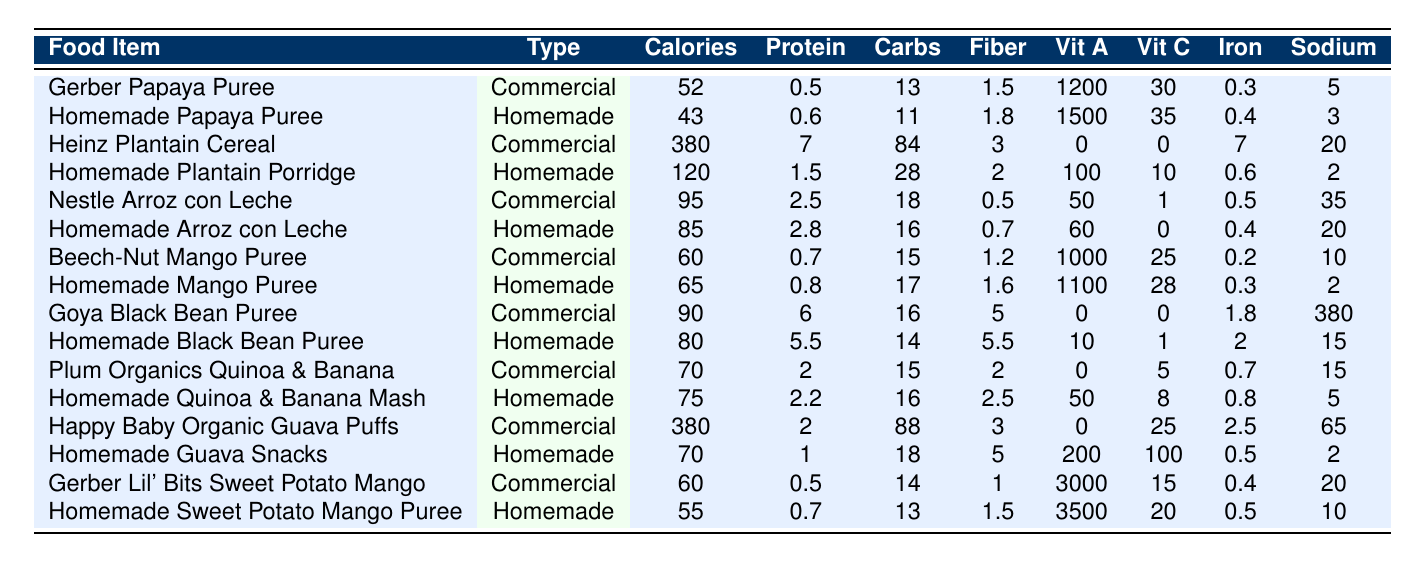What are the calories in Homemade Papaya Puree? The table shows that Homemade Papaya Puree contains 43 calories per 100 grams.
Answer: 43 calories Which food has the highest protein content: Commercial or Homemade? To determine this, we must compare the highest protein values from both categories. The highest protein in the Commercial category is Heinz Plantain Cereal with 7g, while in Homemade, it's Homemade Black Bean Puree with 5.5g. Therefore, Commercial has the highest protein.
Answer: Commercial What is the difference in fiber content between the Homemade and Commercial versions of Arroz con Leche? Homemade Arroz con Leche has 0.7g of fiber, while Commercial Arroz con Leche has 0.5g. The difference is calculated by subtracting 0.5 from 0.7, resulting in a difference of 0.2g.
Answer: 0.2g How much Vitamin A is in Gerber Lil' Bits Sweet Potato Mango? The table indicates that Gerber Lil' Bits Sweet Potato Mango has 3000 IU of Vitamin A per 100 grams.
Answer: 3000 IU Is the sodium content in Goya Black Bean Puree higher than in Homemade Black Bean Puree? Goya Black Bean Puree has 380mg of sodium, while Homemade Black Bean Puree has only 15mg. Thus, the sodium content in Goya Black Bean Puree is significantly higher.
Answer: Yes What is the average protein content of the homemade foods listed? The protein content for Homemade foods is: 0.6 (Papaya) + 1.5 (Plantain Porridge) + 2.8 (Arroz con Leche) + 0.8 (Mango) + 5.5 (Black Bean) + 2.2 (Quinoa & Banana) + 1 (Guava Snacks) + 0.7 (Sweet Potato Mango) = 14.1g. There are 8 homemade foods, so the average is 14.1g/8 = 1.7625g.
Answer: 1.76g Which food item has the highest sodium content? Examining the sodium values, Goya Black Bean Puree has the highest at 380mg.
Answer: Goya Black Bean Puree How does the carbohydrate content of Homemade Quinoa & Banana Mash compare to Commercial Quinoa & Banana? Homemade Quinoa & Banana Mash has 16g of carbohydrates, while the Commercial version has 15g. The Homemade version has 1g more.
Answer: 1g more What is the total calorie count for the Commercial plant-based foods listed? The Commercial plant-based foods and their calorie counts are: Heinz Plantain Cereal (380) + Nestle Arroz con Leche (95) + Beech-Nut Mango Puree (60) + Goya Black Bean Puree (90) + Plum Organics Quinoa & Banana (70) + Happy Baby Organic Guava Puffs (380) + Gerber Lil' Bits Sweet Potato Mango (60) = 1125 calories in total.
Answer: 1125 calories Does Homemade Mango Puree have more Vitamin C than Beech-Nut Mango Puree? Homemade Mango Puree contains 28mg of Vitamin C, while Beech-Nut Mango Puree contains 25mg. Thus, Homemade Mango Puree has more Vitamin C.
Answer: Yes 